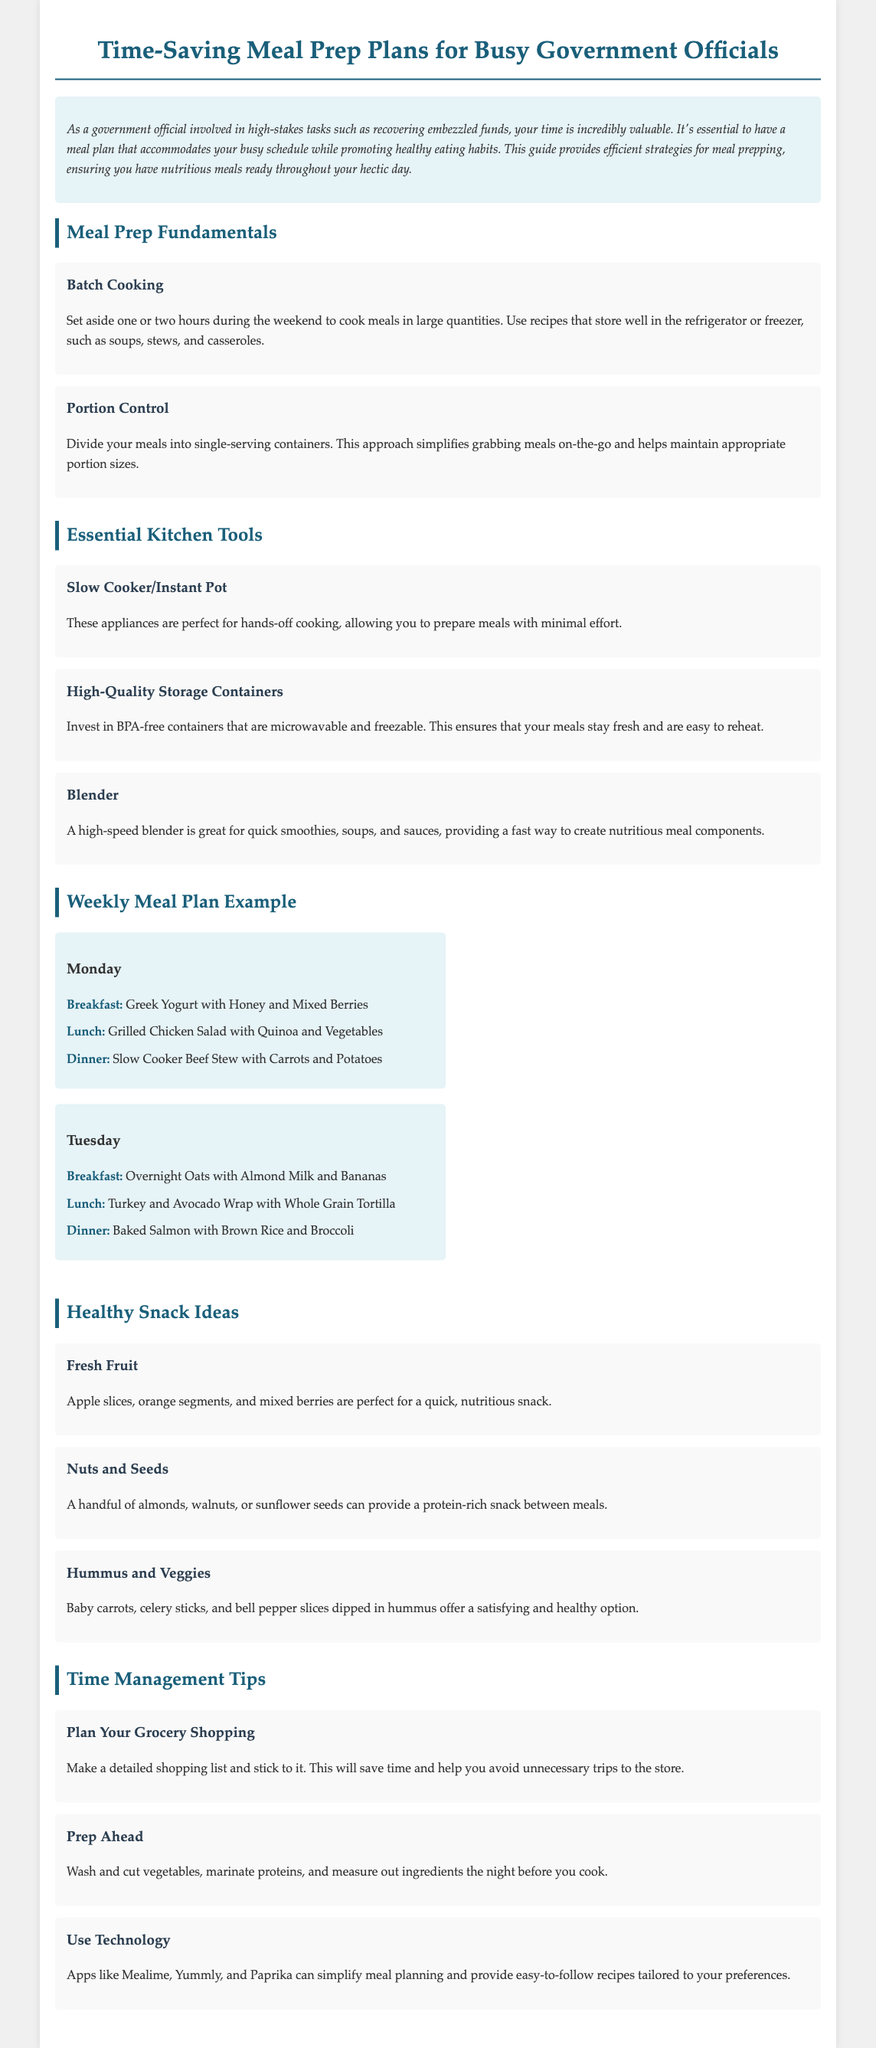What is the title of the document? The title is stated in the header of the document as "Time-Saving Meal Prep Plans for Busy Government Officials."
Answer: Time-Saving Meal Prep Plans for Busy Government Officials What is the main focus of this meal plan? The intro section clarifies that the meal plan focuses on accommodating a busy schedule while promoting healthy eating habits.
Answer: Efficient and Healthy Eating On-the-Go How long should one set aside for batch cooking? The document specifies that you should set aside one or two hours during the weekend for batch cooking.
Answer: One or two hours What is a recommended kitchen tool for hands-off cooking? The document suggests that a Slow Cooker/Instant Pot is ideal for hands-off cooking.
Answer: Slow Cooker/Instant Pot What is included in the breakfast of Monday's meal plan? The document lists "Greek Yogurt with Honey and Mixed Berries" as the breakfast option for Monday.
Answer: Greek Yogurt with Honey and Mixed Berries What healthy snack is mentioned alongside hummus? The document provides "Baby carrots" as a specific vegetable option to dip in hummus.
Answer: Baby carrots What is a key time management tip mentioned in the document? The document advises to "Plan Your Grocery Shopping" as an essential time management tip.
Answer: Plan Your Grocery Shopping Which app is suggested for simplifying meal planning? The document suggests using apps like Mealime, Yummly, and Paprika to simplify meal planning.
Answer: Mealime, Yummly, and Paprika 